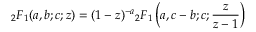Convert formula to latex. <formula><loc_0><loc_0><loc_500><loc_500>{ } _ { 2 } F _ { 1 } ( a , b ; c ; z ) = ( 1 - z ) ^ { - a _ { 2 } F _ { 1 } \left ( a , c - b ; c ; { \frac { z } { z - 1 } } \right )</formula> 